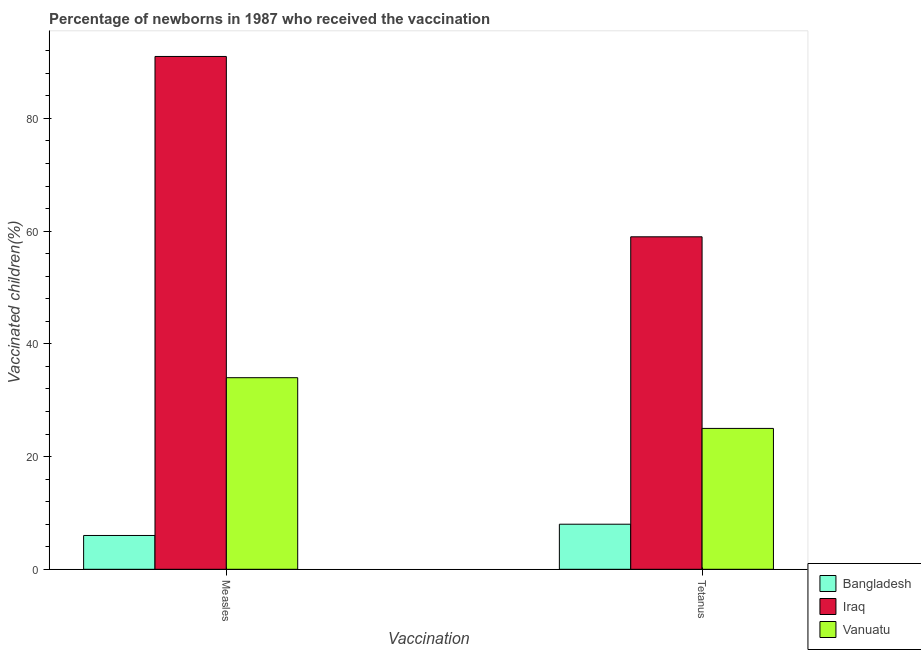How many groups of bars are there?
Offer a very short reply. 2. Are the number of bars per tick equal to the number of legend labels?
Keep it short and to the point. Yes. How many bars are there on the 2nd tick from the left?
Provide a short and direct response. 3. What is the label of the 2nd group of bars from the left?
Make the answer very short. Tetanus. What is the percentage of newborns who received vaccination for measles in Iraq?
Provide a short and direct response. 91. Across all countries, what is the maximum percentage of newborns who received vaccination for measles?
Offer a terse response. 91. Across all countries, what is the minimum percentage of newborns who received vaccination for tetanus?
Give a very brief answer. 8. In which country was the percentage of newborns who received vaccination for measles maximum?
Provide a succinct answer. Iraq. What is the total percentage of newborns who received vaccination for tetanus in the graph?
Offer a very short reply. 92. What is the difference between the percentage of newborns who received vaccination for tetanus in Bangladesh and that in Vanuatu?
Your answer should be compact. -17. What is the difference between the percentage of newborns who received vaccination for measles in Iraq and the percentage of newborns who received vaccination for tetanus in Bangladesh?
Provide a succinct answer. 83. What is the average percentage of newborns who received vaccination for tetanus per country?
Offer a terse response. 30.67. What is the difference between the percentage of newborns who received vaccination for tetanus and percentage of newborns who received vaccination for measles in Bangladesh?
Keep it short and to the point. 2. In how many countries, is the percentage of newborns who received vaccination for tetanus greater than 68 %?
Ensure brevity in your answer.  0. What is the ratio of the percentage of newborns who received vaccination for tetanus in Vanuatu to that in Bangladesh?
Your answer should be compact. 3.12. In how many countries, is the percentage of newborns who received vaccination for measles greater than the average percentage of newborns who received vaccination for measles taken over all countries?
Provide a succinct answer. 1. What does the 2nd bar from the left in Tetanus represents?
Offer a terse response. Iraq. What does the 3rd bar from the right in Measles represents?
Offer a very short reply. Bangladesh. Are all the bars in the graph horizontal?
Offer a terse response. No. How are the legend labels stacked?
Offer a very short reply. Vertical. What is the title of the graph?
Make the answer very short. Percentage of newborns in 1987 who received the vaccination. What is the label or title of the X-axis?
Ensure brevity in your answer.  Vaccination. What is the label or title of the Y-axis?
Provide a succinct answer. Vaccinated children(%)
. What is the Vaccinated children(%)
 in Iraq in Measles?
Your answer should be very brief. 91. What is the Vaccinated children(%)
 of Bangladesh in Tetanus?
Provide a short and direct response. 8. What is the Vaccinated children(%)
 of Vanuatu in Tetanus?
Your response must be concise. 25. Across all Vaccination, what is the maximum Vaccinated children(%)
 in Bangladesh?
Offer a very short reply. 8. Across all Vaccination, what is the maximum Vaccinated children(%)
 in Iraq?
Your answer should be compact. 91. Across all Vaccination, what is the minimum Vaccinated children(%)
 in Iraq?
Offer a terse response. 59. Across all Vaccination, what is the minimum Vaccinated children(%)
 of Vanuatu?
Keep it short and to the point. 25. What is the total Vaccinated children(%)
 in Bangladesh in the graph?
Make the answer very short. 14. What is the total Vaccinated children(%)
 of Iraq in the graph?
Your answer should be very brief. 150. What is the total Vaccinated children(%)
 of Vanuatu in the graph?
Give a very brief answer. 59. What is the difference between the Vaccinated children(%)
 in Bangladesh in Measles and that in Tetanus?
Keep it short and to the point. -2. What is the difference between the Vaccinated children(%)
 in Iraq in Measles and that in Tetanus?
Give a very brief answer. 32. What is the difference between the Vaccinated children(%)
 of Bangladesh in Measles and the Vaccinated children(%)
 of Iraq in Tetanus?
Ensure brevity in your answer.  -53. What is the difference between the Vaccinated children(%)
 of Iraq in Measles and the Vaccinated children(%)
 of Vanuatu in Tetanus?
Your response must be concise. 66. What is the average Vaccinated children(%)
 in Bangladesh per Vaccination?
Your answer should be very brief. 7. What is the average Vaccinated children(%)
 of Vanuatu per Vaccination?
Offer a terse response. 29.5. What is the difference between the Vaccinated children(%)
 in Bangladesh and Vaccinated children(%)
 in Iraq in Measles?
Your answer should be compact. -85. What is the difference between the Vaccinated children(%)
 in Bangladesh and Vaccinated children(%)
 in Iraq in Tetanus?
Provide a succinct answer. -51. What is the ratio of the Vaccinated children(%)
 of Iraq in Measles to that in Tetanus?
Your response must be concise. 1.54. What is the ratio of the Vaccinated children(%)
 in Vanuatu in Measles to that in Tetanus?
Keep it short and to the point. 1.36. What is the difference between the highest and the second highest Vaccinated children(%)
 of Bangladesh?
Your answer should be very brief. 2. What is the difference between the highest and the second highest Vaccinated children(%)
 of Vanuatu?
Give a very brief answer. 9. What is the difference between the highest and the lowest Vaccinated children(%)
 of Bangladesh?
Offer a terse response. 2. 